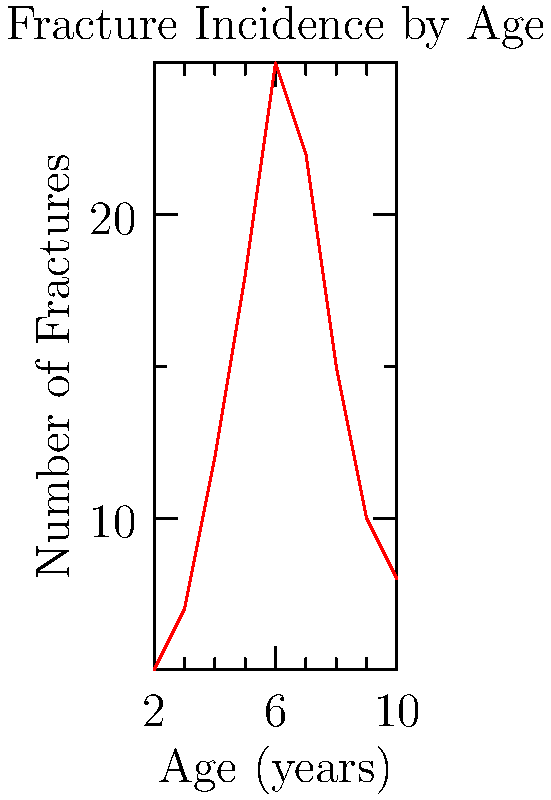As a crime novelist researching child abuse cases, you come across this graph showing fracture incidence by age in a pediatric population. Which age group shows the highest number of fractures, and what could this potentially indicate about child abuse patterns? 1. Analyze the graph: The x-axis represents age in years, while the y-axis shows the number of fractures.

2. Identify the peak: The graph reaches its highest point at age 6, with approximately 25 fractures.

3. Consider child development: Children aged 6 are typically more active but still developing coordination, which could explain some accidental injuries.

4. Evaluate abuse patterns: However, this age group is also vulnerable to abuse as they begin school and interact more outside the home.

5. Compare to other ages: The sharp increase from ages 2-6 and subsequent decline might suggest a pattern beyond normal childhood accidents.

6. Interpret the data: While not conclusive of abuse, the peak at age 6 warrants further investigation, especially in cases with multiple or suspicious fractures.

7. Consider the novelist's perspective: This data could inform character development or plot points in a crime novel focusing on child welfare.
Answer: Age 6; potential increased vulnerability to abuse as children start school and expand social interactions. 